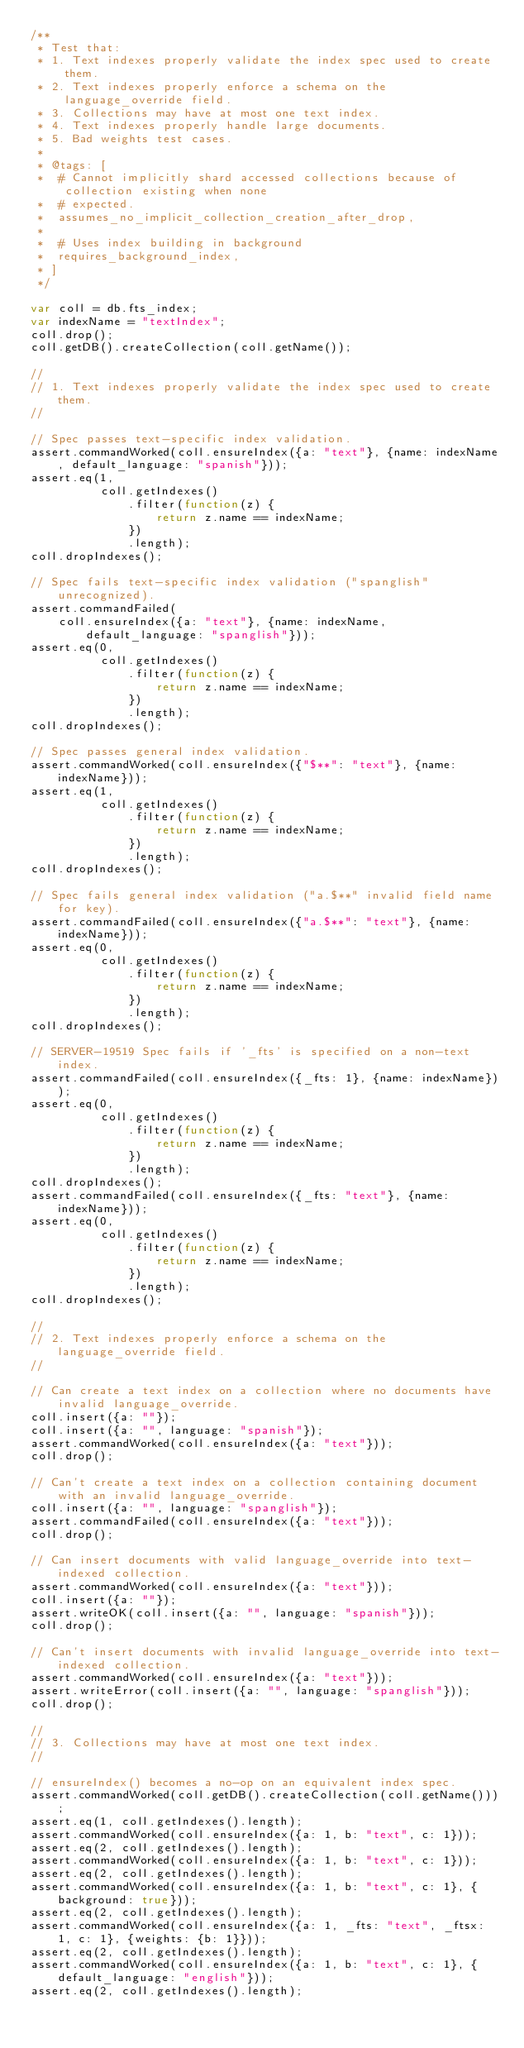<code> <loc_0><loc_0><loc_500><loc_500><_JavaScript_>/**
 * Test that:
 * 1. Text indexes properly validate the index spec used to create them.
 * 2. Text indexes properly enforce a schema on the language_override field.
 * 3. Collections may have at most one text index.
 * 4. Text indexes properly handle large documents.
 * 5. Bad weights test cases.
 *
 * @tags: [
 *  # Cannot implicitly shard accessed collections because of collection existing when none
 *  # expected.
 *  assumes_no_implicit_collection_creation_after_drop,
 *
 *  # Uses index building in background
 *  requires_background_index,
 * ]
 */

var coll = db.fts_index;
var indexName = "textIndex";
coll.drop();
coll.getDB().createCollection(coll.getName());

//
// 1. Text indexes properly validate the index spec used to create them.
//

// Spec passes text-specific index validation.
assert.commandWorked(coll.ensureIndex({a: "text"}, {name: indexName, default_language: "spanish"}));
assert.eq(1,
          coll.getIndexes()
              .filter(function(z) {
                  return z.name == indexName;
              })
              .length);
coll.dropIndexes();

// Spec fails text-specific index validation ("spanglish" unrecognized).
assert.commandFailed(
    coll.ensureIndex({a: "text"}, {name: indexName, default_language: "spanglish"}));
assert.eq(0,
          coll.getIndexes()
              .filter(function(z) {
                  return z.name == indexName;
              })
              .length);
coll.dropIndexes();

// Spec passes general index validation.
assert.commandWorked(coll.ensureIndex({"$**": "text"}, {name: indexName}));
assert.eq(1,
          coll.getIndexes()
              .filter(function(z) {
                  return z.name == indexName;
              })
              .length);
coll.dropIndexes();

// Spec fails general index validation ("a.$**" invalid field name for key).
assert.commandFailed(coll.ensureIndex({"a.$**": "text"}, {name: indexName}));
assert.eq(0,
          coll.getIndexes()
              .filter(function(z) {
                  return z.name == indexName;
              })
              .length);
coll.dropIndexes();

// SERVER-19519 Spec fails if '_fts' is specified on a non-text index.
assert.commandFailed(coll.ensureIndex({_fts: 1}, {name: indexName}));
assert.eq(0,
          coll.getIndexes()
              .filter(function(z) {
                  return z.name == indexName;
              })
              .length);
coll.dropIndexes();
assert.commandFailed(coll.ensureIndex({_fts: "text"}, {name: indexName}));
assert.eq(0,
          coll.getIndexes()
              .filter(function(z) {
                  return z.name == indexName;
              })
              .length);
coll.dropIndexes();

//
// 2. Text indexes properly enforce a schema on the language_override field.
//

// Can create a text index on a collection where no documents have invalid language_override.
coll.insert({a: ""});
coll.insert({a: "", language: "spanish"});
assert.commandWorked(coll.ensureIndex({a: "text"}));
coll.drop();

// Can't create a text index on a collection containing document with an invalid language_override.
coll.insert({a: "", language: "spanglish"});
assert.commandFailed(coll.ensureIndex({a: "text"}));
coll.drop();

// Can insert documents with valid language_override into text-indexed collection.
assert.commandWorked(coll.ensureIndex({a: "text"}));
coll.insert({a: ""});
assert.writeOK(coll.insert({a: "", language: "spanish"}));
coll.drop();

// Can't insert documents with invalid language_override into text-indexed collection.
assert.commandWorked(coll.ensureIndex({a: "text"}));
assert.writeError(coll.insert({a: "", language: "spanglish"}));
coll.drop();

//
// 3. Collections may have at most one text index.
//

// ensureIndex() becomes a no-op on an equivalent index spec.
assert.commandWorked(coll.getDB().createCollection(coll.getName()));
assert.eq(1, coll.getIndexes().length);
assert.commandWorked(coll.ensureIndex({a: 1, b: "text", c: 1}));
assert.eq(2, coll.getIndexes().length);
assert.commandWorked(coll.ensureIndex({a: 1, b: "text", c: 1}));
assert.eq(2, coll.getIndexes().length);
assert.commandWorked(coll.ensureIndex({a: 1, b: "text", c: 1}, {background: true}));
assert.eq(2, coll.getIndexes().length);
assert.commandWorked(coll.ensureIndex({a: 1, _fts: "text", _ftsx: 1, c: 1}, {weights: {b: 1}}));
assert.eq(2, coll.getIndexes().length);
assert.commandWorked(coll.ensureIndex({a: 1, b: "text", c: 1}, {default_language: "english"}));
assert.eq(2, coll.getIndexes().length);</code> 